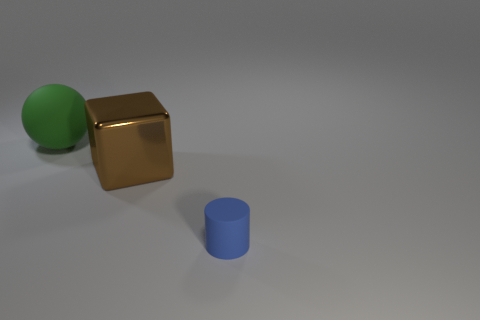Add 3 tiny metallic blocks. How many objects exist? 6 Add 2 tiny blue objects. How many tiny blue objects exist? 3 Subtract 0 yellow spheres. How many objects are left? 3 Subtract all blocks. How many objects are left? 2 Subtract all gray cylinders. Subtract all red blocks. How many cylinders are left? 1 Subtract all rubber objects. Subtract all large brown cubes. How many objects are left? 0 Add 3 brown blocks. How many brown blocks are left? 4 